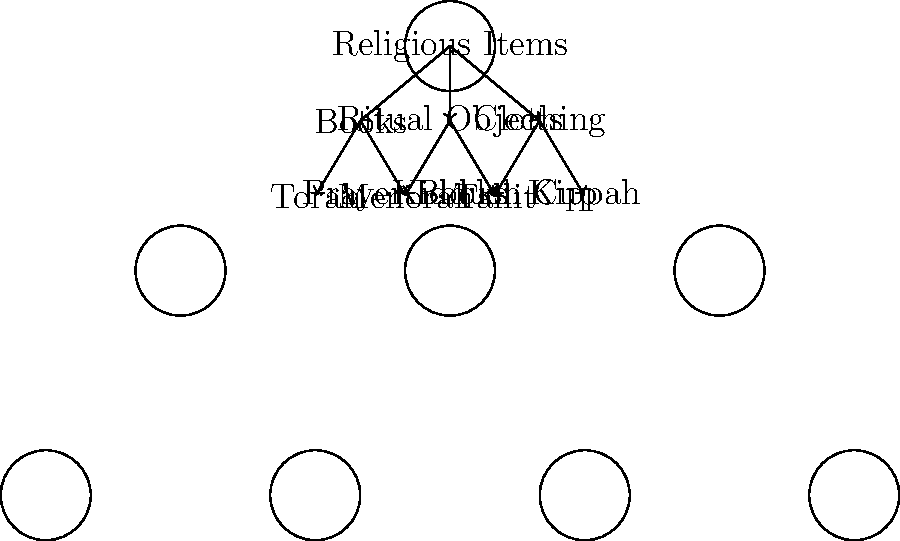Given the hierarchical tree diagram of religious items inventory for a synagogue, calculate the total number of leaf nodes and determine the maximum depth of the tree. How would this information be useful for inventory management? To solve this problem, let's break it down into steps:

1. Counting leaf nodes:
   - Leaf nodes are nodes with no children.
   - In this diagram, the leaf nodes are: Torah, Prayer Books, Menorah, Kiddush Cup, Tallit, and Kippah.
   - Total number of leaf nodes = 6

2. Determining the maximum depth of the tree:
   - The depth of a node is the number of edges from the root to that node.
   - Root ("Religious Items") has depth 0.
   - First level (Books, Ritual Objects, Clothing) has depth 1.
   - Second level (Torah, Prayer Books, Menorah, Kiddush Cup, Tallit, Kippah) has depth 2.
   - The maximum depth is 2.

3. Usefulness for inventory management:
   a) Number of leaf nodes (6):
      - Represents the variety of specific items to be managed.
      - Helps in determining the complexity of the inventory system.
      - Aids in planning storage space and organization.

   b) Maximum depth (2):
      - Indicates the levels of categorization in the inventory.
      - Helps in creating a logical filing system or database structure.
      - Useful for designing user interfaces for inventory management software.

   c) Combined use:
      - Assists in creating an efficient inventory counting system.
      - Helps in developing a balanced and organized storage system.
      - Useful for training staff on the structure of the inventory.

The tree structure with 6 leaf nodes and a depth of 2 suggests a well-organized, moderately complex inventory system that is manageable but requires attention to detail in categorization and storage.
Answer: 6 leaf nodes, depth 2; aids in organization, storage planning, and system design. 